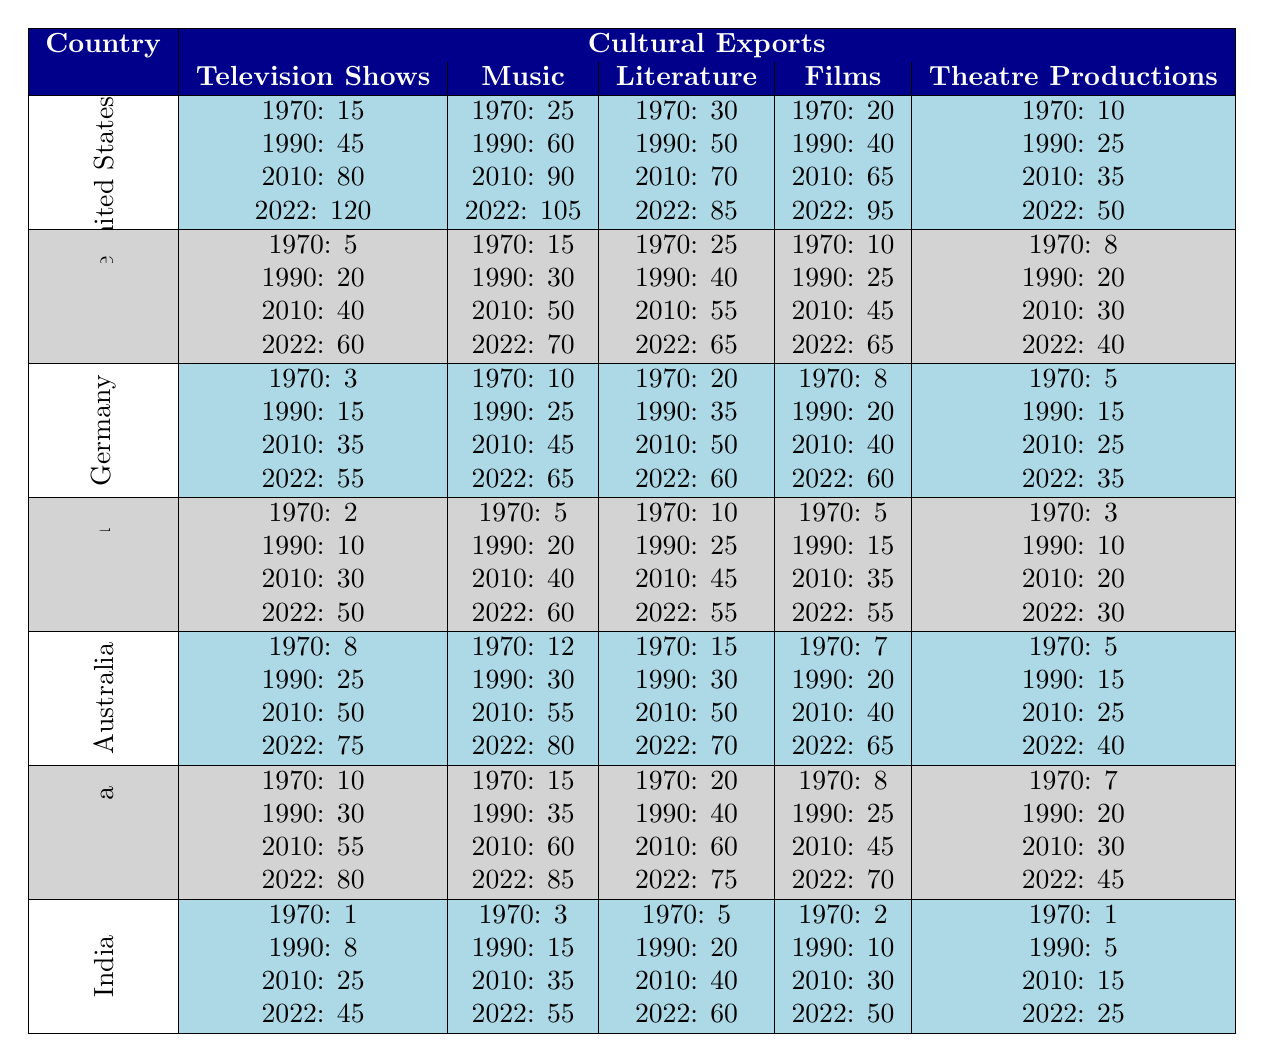What were the total cultural exports to the United States in 2022? To find the total cultural exports to the United States in 2022, we need to sum the values of all exports in that year: Television Shows (120) + Music (105) + Literature (85) + Films (95) + Theatre Productions (50) = 455.
Answer: 455 Which country had the highest number of films exported from the UK in 2022? Looking at the Films row for 2022, the United States exported 95 films, France exported 65, Germany 60, Japan 55, Australia 65, Canada 70, and India 50. The highest value is 95 from the United States.
Answer: United States What is the percentage increase in music exports to Canada from 1970 to 2022? The music exports to Canada in 1970 were 15, and in 2022 it was 85. The increase is 85 - 15 = 70. The percentage increase is (70/15) * 100 = 466.67%.
Answer: 466.67% Did Japanese cultural exports in literature decrease at any point from 1970 to 2022? Examining the Literature row for Japan, the values are 10 (1970), 25 (1990), 45 (2010), and 55 (2022). There is no decrease across these years; the values only increased.
Answer: No What is the total number of theatre productions exported to Australia from 1970 to 2022? To find the total theatre productions to Australia over the years, add: 5 (1970) + 15 (1990) + 25 (2010) + 40 (2022) = 85.
Answer: 85 Which cultural export showed the least growth in Germany from 1970 to 2022? In Germany, the growth for each cultural export from 1970 to 2022 is: Television Shows (3 to 55 = 52), Music (10 to 65 = 55), Literature (20 to 60 = 40), Films (8 to 60 = 52), Theatre Productions (5 to 35 = 30). The least growth is in Theatre Productions with an increase of 30.
Answer: Theatre Productions What was the average number of television shows exported from the UK to India over the years? The number of television shows exported to India each year is 1 (1970), 8 (1990), 25 (2010), and 45 (2022). The average is (1 + 8 + 25 + 45) / 4 = 19.75.
Answer: 19.75 Did Canada export more literature or theatre productions in 2010? In 2010, Canada exported 60 literature pieces and 30 theatre productions. Thus, Canada exported more literature than theatre productions in 2010.
Answer: Yes What was the difference in the number of music exports from Australia between 1990 and 2022? In Australia, the music exports were 30 in 1990 and 80 in 2022. The difference is 80 - 30 = 50.
Answer: 50 Which country had the lowest exports in television shows in 1970? The values for television shows in 1970 are: United States (15), France (5), Germany (3), Japan (2), Australia (8), Canada (10), India (1). The lowest value is from India with 1 television show.
Answer: India 